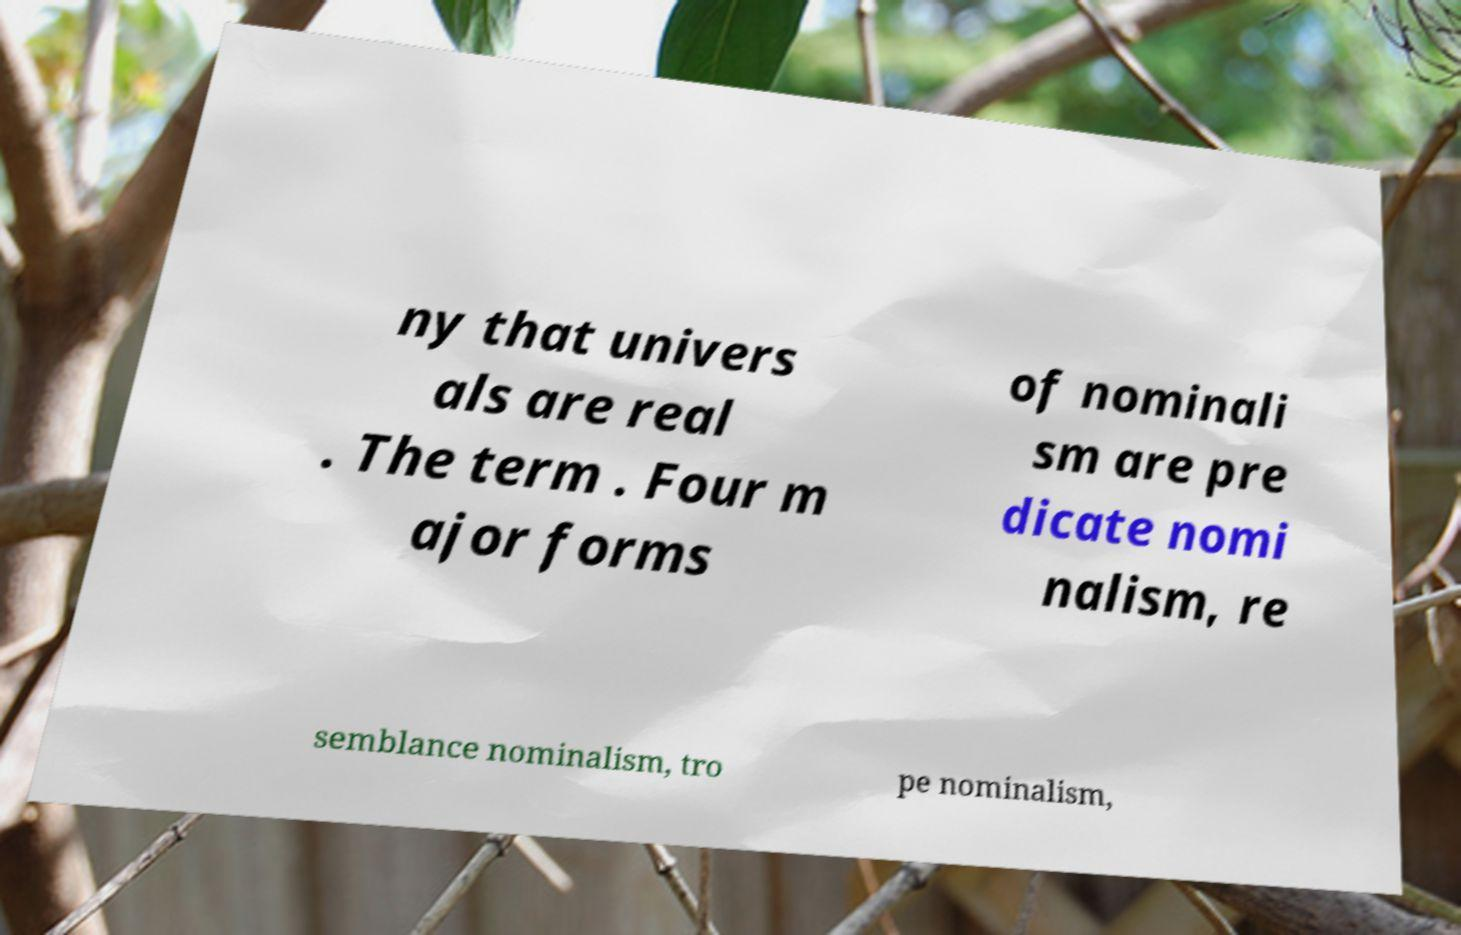Please identify and transcribe the text found in this image. ny that univers als are real . The term . Four m ajor forms of nominali sm are pre dicate nomi nalism, re semblance nominalism, tro pe nominalism, 